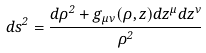Convert formula to latex. <formula><loc_0><loc_0><loc_500><loc_500>d s ^ { 2 } = \frac { d \rho ^ { 2 } + g _ { \mu \nu } ( \rho , z ) d z ^ { \mu } d z ^ { \nu } } { \rho ^ { 2 } } \\</formula> 